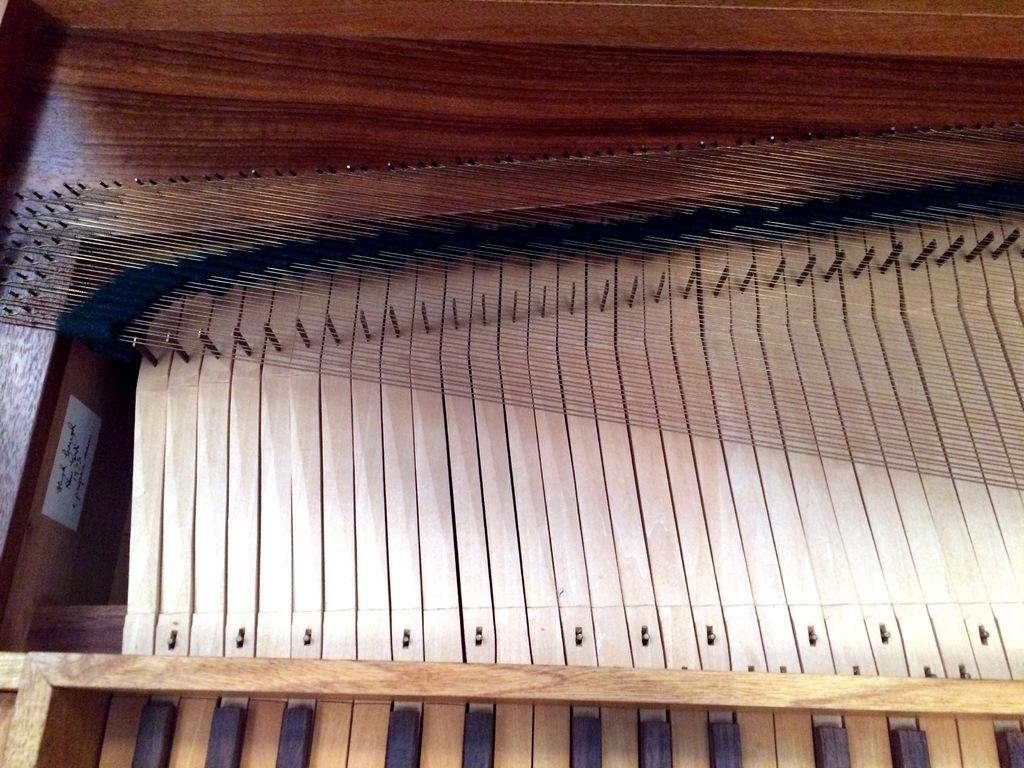What object in the image is associated with creating music? There is a musical instrument in the image. What material is the musical instrument made of? The musical instrument is made up of wood. Reasoning: Let' Let's think step by step in order to produce the conversation. We start by identifying the main subject in the image, which is the musical instrument. Then, we expand the conversation to include the material used to make the instrument, which is wood. Each question is designed to elicit a specific detail about the image that is known from the provided facts. Absurd Question/Answer: What type of knowledge can be gained from the grass in the image? There is no grass present in the image, so no knowledge can be gained from it. 